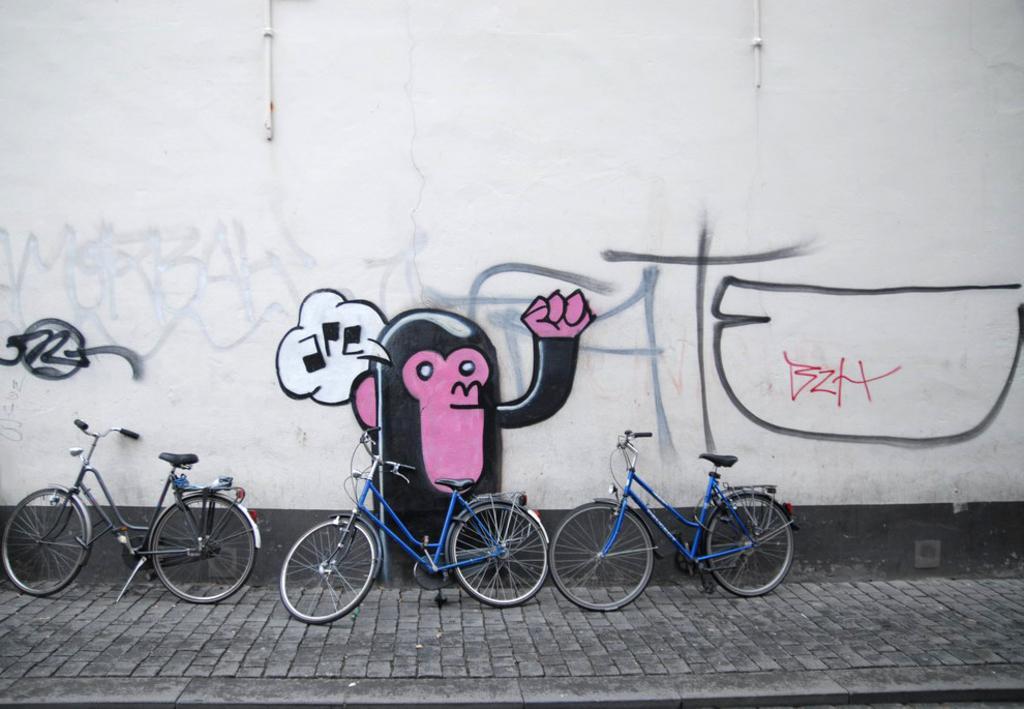Describe this image in one or two sentences. In this image in front there are cycles. Behind the cycles there's a wall with painting on it. 